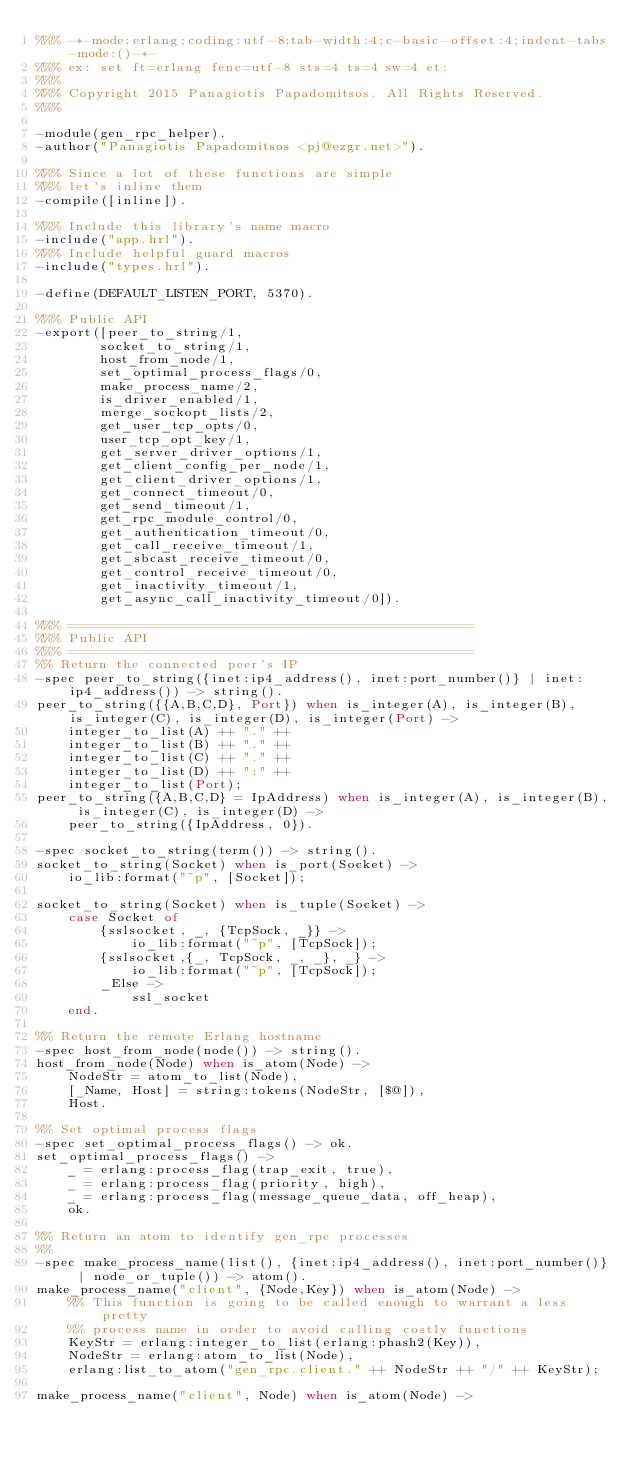Convert code to text. <code><loc_0><loc_0><loc_500><loc_500><_Erlang_>%%% -*-mode:erlang;coding:utf-8;tab-width:4;c-basic-offset:4;indent-tabs-mode:()-*-
%%% ex: set ft=erlang fenc=utf-8 sts=4 ts=4 sw=4 et:
%%%
%%% Copyright 2015 Panagiotis Papadomitsos. All Rights Reserved.
%%%

-module(gen_rpc_helper).
-author("Panagiotis Papadomitsos <pj@ezgr.net>").

%%% Since a lot of these functions are simple
%%% let's inline them
-compile([inline]).

%%% Include this library's name macro
-include("app.hrl").
%%% Include helpful guard macros
-include("types.hrl").

-define(DEFAULT_LISTEN_PORT, 5370).

%%% Public API
-export([peer_to_string/1,
        socket_to_string/1,
        host_from_node/1,
        set_optimal_process_flags/0,
        make_process_name/2,
        is_driver_enabled/1,
        merge_sockopt_lists/2,
        get_user_tcp_opts/0,
        user_tcp_opt_key/1,
        get_server_driver_options/1,
        get_client_config_per_node/1,
        get_client_driver_options/1,
        get_connect_timeout/0,
        get_send_timeout/1,
        get_rpc_module_control/0,
        get_authentication_timeout/0,
        get_call_receive_timeout/1,
        get_sbcast_receive_timeout/0,
        get_control_receive_timeout/0,
        get_inactivity_timeout/1,
        get_async_call_inactivity_timeout/0]).

%%% ===================================================
%%% Public API
%%% ===================================================
%% Return the connected peer's IP
-spec peer_to_string({inet:ip4_address(), inet:port_number()} | inet:ip4_address()) -> string().
peer_to_string({{A,B,C,D}, Port}) when is_integer(A), is_integer(B), is_integer(C), is_integer(D), is_integer(Port) ->
    integer_to_list(A) ++ "." ++
    integer_to_list(B) ++ "." ++
    integer_to_list(C) ++ "." ++
    integer_to_list(D) ++ ":" ++
    integer_to_list(Port);
peer_to_string({A,B,C,D} = IpAddress) when is_integer(A), is_integer(B), is_integer(C), is_integer(D) ->
    peer_to_string({IpAddress, 0}).

-spec socket_to_string(term()) -> string().
socket_to_string(Socket) when is_port(Socket) ->
    io_lib:format("~p", [Socket]);

socket_to_string(Socket) when is_tuple(Socket) ->
    case Socket of
        {sslsocket, _, {TcpSock, _}} ->
            io_lib:format("~p", [TcpSock]);
        {sslsocket,{_, TcpSock, _, _}, _} ->
            io_lib:format("~p", [TcpSock]);
        _Else ->
            ssl_socket
    end.

%% Return the remote Erlang hostname
-spec host_from_node(node()) -> string().
host_from_node(Node) when is_atom(Node) ->
    NodeStr = atom_to_list(Node),
    [_Name, Host] = string:tokens(NodeStr, [$@]),
    Host.

%% Set optimal process flags
-spec set_optimal_process_flags() -> ok.
set_optimal_process_flags() ->
    _ = erlang:process_flag(trap_exit, true),
    _ = erlang:process_flag(priority, high),
    _ = erlang:process_flag(message_queue_data, off_heap),
    ok.

%% Return an atom to identify gen_rpc processes
%%
-spec make_process_name(list(), {inet:ip4_address(), inet:port_number()} | node_or_tuple()) -> atom().
make_process_name("client", {Node,Key}) when is_atom(Node) ->
    %% This function is going to be called enough to warrant a less pretty
    %% process name in order to avoid calling costly functions
    KeyStr = erlang:integer_to_list(erlang:phash2(Key)),
    NodeStr = erlang:atom_to_list(Node),
    erlang:list_to_atom("gen_rpc.client." ++ NodeStr ++ "/" ++ KeyStr);

make_process_name("client", Node) when is_atom(Node) -></code> 